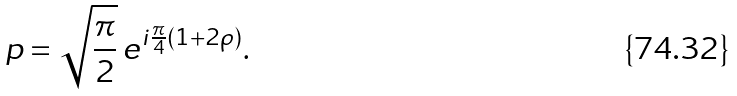<formula> <loc_0><loc_0><loc_500><loc_500>p = \sqrt { \frac { \pi } { 2 } } \, e ^ { i \frac { \pi } { 4 } ( 1 + 2 \rho ) } .</formula> 